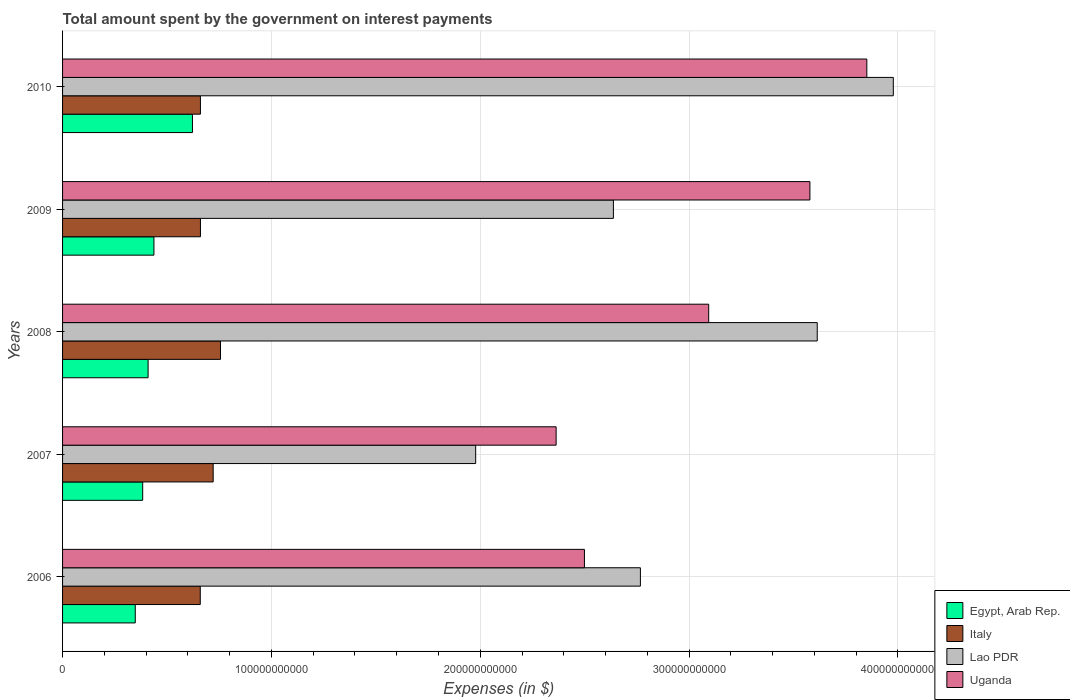How many different coloured bars are there?
Your answer should be compact. 4. How many groups of bars are there?
Make the answer very short. 5. Are the number of bars per tick equal to the number of legend labels?
Offer a terse response. Yes. How many bars are there on the 1st tick from the top?
Keep it short and to the point. 4. What is the label of the 4th group of bars from the top?
Your answer should be very brief. 2007. In how many cases, is the number of bars for a given year not equal to the number of legend labels?
Offer a terse response. 0. What is the amount spent on interest payments by the government in Egypt, Arab Rep. in 2006?
Provide a short and direct response. 3.48e+1. Across all years, what is the maximum amount spent on interest payments by the government in Egypt, Arab Rep.?
Your response must be concise. 6.22e+1. Across all years, what is the minimum amount spent on interest payments by the government in Uganda?
Your answer should be very brief. 2.36e+11. In which year was the amount spent on interest payments by the government in Uganda maximum?
Ensure brevity in your answer.  2010. In which year was the amount spent on interest payments by the government in Lao PDR minimum?
Your answer should be very brief. 2007. What is the total amount spent on interest payments by the government in Uganda in the graph?
Ensure brevity in your answer.  1.54e+12. What is the difference between the amount spent on interest payments by the government in Uganda in 2007 and that in 2008?
Make the answer very short. -7.31e+1. What is the difference between the amount spent on interest payments by the government in Uganda in 2009 and the amount spent on interest payments by the government in Italy in 2007?
Offer a terse response. 2.86e+11. What is the average amount spent on interest payments by the government in Uganda per year?
Make the answer very short. 3.08e+11. In the year 2008, what is the difference between the amount spent on interest payments by the government in Egypt, Arab Rep. and amount spent on interest payments by the government in Italy?
Keep it short and to the point. -3.47e+1. What is the ratio of the amount spent on interest payments by the government in Egypt, Arab Rep. in 2006 to that in 2007?
Make the answer very short. 0.91. Is the amount spent on interest payments by the government in Uganda in 2008 less than that in 2009?
Provide a short and direct response. Yes. What is the difference between the highest and the second highest amount spent on interest payments by the government in Italy?
Provide a short and direct response. 3.50e+09. What is the difference between the highest and the lowest amount spent on interest payments by the government in Egypt, Arab Rep.?
Your answer should be compact. 2.74e+1. What does the 3rd bar from the bottom in 2006 represents?
Make the answer very short. Lao PDR. Are all the bars in the graph horizontal?
Keep it short and to the point. Yes. What is the difference between two consecutive major ticks on the X-axis?
Provide a short and direct response. 1.00e+11. Are the values on the major ticks of X-axis written in scientific E-notation?
Offer a terse response. No. Does the graph contain any zero values?
Give a very brief answer. No. Does the graph contain grids?
Make the answer very short. Yes. Where does the legend appear in the graph?
Keep it short and to the point. Bottom right. How are the legend labels stacked?
Offer a terse response. Vertical. What is the title of the graph?
Your answer should be very brief. Total amount spent by the government on interest payments. What is the label or title of the X-axis?
Offer a very short reply. Expenses (in $). What is the Expenses (in $) of Egypt, Arab Rep. in 2006?
Make the answer very short. 3.48e+1. What is the Expenses (in $) in Italy in 2006?
Your answer should be compact. 6.59e+1. What is the Expenses (in $) of Lao PDR in 2006?
Provide a succinct answer. 2.77e+11. What is the Expenses (in $) in Uganda in 2006?
Make the answer very short. 2.50e+11. What is the Expenses (in $) of Egypt, Arab Rep. in 2007?
Ensure brevity in your answer.  3.84e+1. What is the Expenses (in $) in Italy in 2007?
Your answer should be compact. 7.21e+1. What is the Expenses (in $) of Lao PDR in 2007?
Make the answer very short. 1.98e+11. What is the Expenses (in $) in Uganda in 2007?
Keep it short and to the point. 2.36e+11. What is the Expenses (in $) of Egypt, Arab Rep. in 2008?
Your response must be concise. 4.10e+1. What is the Expenses (in $) of Italy in 2008?
Your answer should be very brief. 7.56e+1. What is the Expenses (in $) of Lao PDR in 2008?
Make the answer very short. 3.61e+11. What is the Expenses (in $) in Uganda in 2008?
Make the answer very short. 3.09e+11. What is the Expenses (in $) of Egypt, Arab Rep. in 2009?
Keep it short and to the point. 4.38e+1. What is the Expenses (in $) in Italy in 2009?
Make the answer very short. 6.60e+1. What is the Expenses (in $) in Lao PDR in 2009?
Your answer should be very brief. 2.64e+11. What is the Expenses (in $) in Uganda in 2009?
Your answer should be compact. 3.58e+11. What is the Expenses (in $) in Egypt, Arab Rep. in 2010?
Give a very brief answer. 6.22e+1. What is the Expenses (in $) of Italy in 2010?
Provide a short and direct response. 6.60e+1. What is the Expenses (in $) of Lao PDR in 2010?
Provide a short and direct response. 3.98e+11. What is the Expenses (in $) in Uganda in 2010?
Ensure brevity in your answer.  3.85e+11. Across all years, what is the maximum Expenses (in $) of Egypt, Arab Rep.?
Offer a very short reply. 6.22e+1. Across all years, what is the maximum Expenses (in $) of Italy?
Keep it short and to the point. 7.56e+1. Across all years, what is the maximum Expenses (in $) of Lao PDR?
Offer a terse response. 3.98e+11. Across all years, what is the maximum Expenses (in $) of Uganda?
Your answer should be compact. 3.85e+11. Across all years, what is the minimum Expenses (in $) in Egypt, Arab Rep.?
Keep it short and to the point. 3.48e+1. Across all years, what is the minimum Expenses (in $) of Italy?
Your response must be concise. 6.59e+1. Across all years, what is the minimum Expenses (in $) of Lao PDR?
Ensure brevity in your answer.  1.98e+11. Across all years, what is the minimum Expenses (in $) in Uganda?
Offer a terse response. 2.36e+11. What is the total Expenses (in $) in Egypt, Arab Rep. in the graph?
Provide a succinct answer. 2.20e+11. What is the total Expenses (in $) in Italy in the graph?
Offer a very short reply. 3.46e+11. What is the total Expenses (in $) in Lao PDR in the graph?
Ensure brevity in your answer.  1.50e+12. What is the total Expenses (in $) in Uganda in the graph?
Your answer should be compact. 1.54e+12. What is the difference between the Expenses (in $) in Egypt, Arab Rep. in 2006 and that in 2007?
Offer a terse response. -3.56e+09. What is the difference between the Expenses (in $) in Italy in 2006 and that in 2007?
Your answer should be compact. -6.18e+09. What is the difference between the Expenses (in $) in Lao PDR in 2006 and that in 2007?
Your response must be concise. 7.89e+1. What is the difference between the Expenses (in $) in Uganda in 2006 and that in 2007?
Ensure brevity in your answer.  1.36e+1. What is the difference between the Expenses (in $) in Egypt, Arab Rep. in 2006 and that in 2008?
Provide a succinct answer. -6.14e+09. What is the difference between the Expenses (in $) of Italy in 2006 and that in 2008?
Provide a succinct answer. -9.68e+09. What is the difference between the Expenses (in $) in Lao PDR in 2006 and that in 2008?
Offer a terse response. -8.47e+1. What is the difference between the Expenses (in $) in Uganda in 2006 and that in 2008?
Make the answer very short. -5.95e+1. What is the difference between the Expenses (in $) in Egypt, Arab Rep. in 2006 and that in 2009?
Provide a short and direct response. -8.94e+09. What is the difference between the Expenses (in $) of Italy in 2006 and that in 2009?
Provide a short and direct response. -8.80e+07. What is the difference between the Expenses (in $) in Lao PDR in 2006 and that in 2009?
Provide a succinct answer. 1.29e+1. What is the difference between the Expenses (in $) in Uganda in 2006 and that in 2009?
Offer a terse response. -1.08e+11. What is the difference between the Expenses (in $) in Egypt, Arab Rep. in 2006 and that in 2010?
Your answer should be compact. -2.74e+1. What is the difference between the Expenses (in $) of Italy in 2006 and that in 2010?
Provide a short and direct response. -7.20e+07. What is the difference between the Expenses (in $) of Lao PDR in 2006 and that in 2010?
Make the answer very short. -1.21e+11. What is the difference between the Expenses (in $) in Uganda in 2006 and that in 2010?
Offer a very short reply. -1.35e+11. What is the difference between the Expenses (in $) in Egypt, Arab Rep. in 2007 and that in 2008?
Offer a very short reply. -2.59e+09. What is the difference between the Expenses (in $) in Italy in 2007 and that in 2008?
Offer a terse response. -3.50e+09. What is the difference between the Expenses (in $) in Lao PDR in 2007 and that in 2008?
Make the answer very short. -1.64e+11. What is the difference between the Expenses (in $) of Uganda in 2007 and that in 2008?
Give a very brief answer. -7.31e+1. What is the difference between the Expenses (in $) in Egypt, Arab Rep. in 2007 and that in 2009?
Give a very brief answer. -5.39e+09. What is the difference between the Expenses (in $) of Italy in 2007 and that in 2009?
Your answer should be very brief. 6.09e+09. What is the difference between the Expenses (in $) in Lao PDR in 2007 and that in 2009?
Ensure brevity in your answer.  -6.60e+1. What is the difference between the Expenses (in $) of Uganda in 2007 and that in 2009?
Your answer should be compact. -1.22e+11. What is the difference between the Expenses (in $) of Egypt, Arab Rep. in 2007 and that in 2010?
Provide a succinct answer. -2.38e+1. What is the difference between the Expenses (in $) in Italy in 2007 and that in 2010?
Provide a succinct answer. 6.11e+09. What is the difference between the Expenses (in $) of Lao PDR in 2007 and that in 2010?
Keep it short and to the point. -2.00e+11. What is the difference between the Expenses (in $) in Uganda in 2007 and that in 2010?
Keep it short and to the point. -1.49e+11. What is the difference between the Expenses (in $) in Egypt, Arab Rep. in 2008 and that in 2009?
Offer a terse response. -2.80e+09. What is the difference between the Expenses (in $) in Italy in 2008 and that in 2009?
Provide a succinct answer. 9.59e+09. What is the difference between the Expenses (in $) in Lao PDR in 2008 and that in 2009?
Offer a terse response. 9.76e+1. What is the difference between the Expenses (in $) in Uganda in 2008 and that in 2009?
Your response must be concise. -4.85e+1. What is the difference between the Expenses (in $) in Egypt, Arab Rep. in 2008 and that in 2010?
Your response must be concise. -2.12e+1. What is the difference between the Expenses (in $) in Italy in 2008 and that in 2010?
Keep it short and to the point. 9.61e+09. What is the difference between the Expenses (in $) of Lao PDR in 2008 and that in 2010?
Your response must be concise. -3.64e+1. What is the difference between the Expenses (in $) in Uganda in 2008 and that in 2010?
Ensure brevity in your answer.  -7.57e+1. What is the difference between the Expenses (in $) in Egypt, Arab Rep. in 2009 and that in 2010?
Ensure brevity in your answer.  -1.84e+1. What is the difference between the Expenses (in $) in Italy in 2009 and that in 2010?
Make the answer very short. 1.60e+07. What is the difference between the Expenses (in $) of Lao PDR in 2009 and that in 2010?
Offer a terse response. -1.34e+11. What is the difference between the Expenses (in $) in Uganda in 2009 and that in 2010?
Make the answer very short. -2.73e+1. What is the difference between the Expenses (in $) of Egypt, Arab Rep. in 2006 and the Expenses (in $) of Italy in 2007?
Ensure brevity in your answer.  -3.73e+1. What is the difference between the Expenses (in $) of Egypt, Arab Rep. in 2006 and the Expenses (in $) of Lao PDR in 2007?
Your answer should be very brief. -1.63e+11. What is the difference between the Expenses (in $) of Egypt, Arab Rep. in 2006 and the Expenses (in $) of Uganda in 2007?
Provide a succinct answer. -2.02e+11. What is the difference between the Expenses (in $) of Italy in 2006 and the Expenses (in $) of Lao PDR in 2007?
Make the answer very short. -1.32e+11. What is the difference between the Expenses (in $) in Italy in 2006 and the Expenses (in $) in Uganda in 2007?
Keep it short and to the point. -1.70e+11. What is the difference between the Expenses (in $) in Lao PDR in 2006 and the Expenses (in $) in Uganda in 2007?
Offer a very short reply. 4.04e+1. What is the difference between the Expenses (in $) in Egypt, Arab Rep. in 2006 and the Expenses (in $) in Italy in 2008?
Your response must be concise. -4.08e+1. What is the difference between the Expenses (in $) of Egypt, Arab Rep. in 2006 and the Expenses (in $) of Lao PDR in 2008?
Keep it short and to the point. -3.27e+11. What is the difference between the Expenses (in $) of Egypt, Arab Rep. in 2006 and the Expenses (in $) of Uganda in 2008?
Provide a short and direct response. -2.75e+11. What is the difference between the Expenses (in $) in Italy in 2006 and the Expenses (in $) in Lao PDR in 2008?
Ensure brevity in your answer.  -2.95e+11. What is the difference between the Expenses (in $) of Italy in 2006 and the Expenses (in $) of Uganda in 2008?
Offer a very short reply. -2.43e+11. What is the difference between the Expenses (in $) of Lao PDR in 2006 and the Expenses (in $) of Uganda in 2008?
Your response must be concise. -3.27e+1. What is the difference between the Expenses (in $) of Egypt, Arab Rep. in 2006 and the Expenses (in $) of Italy in 2009?
Your answer should be compact. -3.12e+1. What is the difference between the Expenses (in $) of Egypt, Arab Rep. in 2006 and the Expenses (in $) of Lao PDR in 2009?
Ensure brevity in your answer.  -2.29e+11. What is the difference between the Expenses (in $) in Egypt, Arab Rep. in 2006 and the Expenses (in $) in Uganda in 2009?
Make the answer very short. -3.23e+11. What is the difference between the Expenses (in $) in Italy in 2006 and the Expenses (in $) in Lao PDR in 2009?
Make the answer very short. -1.98e+11. What is the difference between the Expenses (in $) of Italy in 2006 and the Expenses (in $) of Uganda in 2009?
Provide a succinct answer. -2.92e+11. What is the difference between the Expenses (in $) of Lao PDR in 2006 and the Expenses (in $) of Uganda in 2009?
Give a very brief answer. -8.12e+1. What is the difference between the Expenses (in $) in Egypt, Arab Rep. in 2006 and the Expenses (in $) in Italy in 2010?
Give a very brief answer. -3.12e+1. What is the difference between the Expenses (in $) in Egypt, Arab Rep. in 2006 and the Expenses (in $) in Lao PDR in 2010?
Keep it short and to the point. -3.63e+11. What is the difference between the Expenses (in $) in Egypt, Arab Rep. in 2006 and the Expenses (in $) in Uganda in 2010?
Provide a short and direct response. -3.50e+11. What is the difference between the Expenses (in $) of Italy in 2006 and the Expenses (in $) of Lao PDR in 2010?
Make the answer very short. -3.32e+11. What is the difference between the Expenses (in $) in Italy in 2006 and the Expenses (in $) in Uganda in 2010?
Make the answer very short. -3.19e+11. What is the difference between the Expenses (in $) of Lao PDR in 2006 and the Expenses (in $) of Uganda in 2010?
Give a very brief answer. -1.08e+11. What is the difference between the Expenses (in $) of Egypt, Arab Rep. in 2007 and the Expenses (in $) of Italy in 2008?
Ensure brevity in your answer.  -3.73e+1. What is the difference between the Expenses (in $) in Egypt, Arab Rep. in 2007 and the Expenses (in $) in Lao PDR in 2008?
Give a very brief answer. -3.23e+11. What is the difference between the Expenses (in $) in Egypt, Arab Rep. in 2007 and the Expenses (in $) in Uganda in 2008?
Your answer should be very brief. -2.71e+11. What is the difference between the Expenses (in $) of Italy in 2007 and the Expenses (in $) of Lao PDR in 2008?
Provide a short and direct response. -2.89e+11. What is the difference between the Expenses (in $) in Italy in 2007 and the Expenses (in $) in Uganda in 2008?
Provide a succinct answer. -2.37e+11. What is the difference between the Expenses (in $) of Lao PDR in 2007 and the Expenses (in $) of Uganda in 2008?
Keep it short and to the point. -1.12e+11. What is the difference between the Expenses (in $) of Egypt, Arab Rep. in 2007 and the Expenses (in $) of Italy in 2009?
Your answer should be very brief. -2.77e+1. What is the difference between the Expenses (in $) of Egypt, Arab Rep. in 2007 and the Expenses (in $) of Lao PDR in 2009?
Your answer should be very brief. -2.25e+11. What is the difference between the Expenses (in $) of Egypt, Arab Rep. in 2007 and the Expenses (in $) of Uganda in 2009?
Ensure brevity in your answer.  -3.20e+11. What is the difference between the Expenses (in $) in Italy in 2007 and the Expenses (in $) in Lao PDR in 2009?
Ensure brevity in your answer.  -1.92e+11. What is the difference between the Expenses (in $) in Italy in 2007 and the Expenses (in $) in Uganda in 2009?
Provide a succinct answer. -2.86e+11. What is the difference between the Expenses (in $) of Lao PDR in 2007 and the Expenses (in $) of Uganda in 2009?
Provide a succinct answer. -1.60e+11. What is the difference between the Expenses (in $) in Egypt, Arab Rep. in 2007 and the Expenses (in $) in Italy in 2010?
Ensure brevity in your answer.  -2.76e+1. What is the difference between the Expenses (in $) in Egypt, Arab Rep. in 2007 and the Expenses (in $) in Lao PDR in 2010?
Provide a short and direct response. -3.59e+11. What is the difference between the Expenses (in $) in Egypt, Arab Rep. in 2007 and the Expenses (in $) in Uganda in 2010?
Provide a short and direct response. -3.47e+11. What is the difference between the Expenses (in $) of Italy in 2007 and the Expenses (in $) of Lao PDR in 2010?
Offer a terse response. -3.26e+11. What is the difference between the Expenses (in $) of Italy in 2007 and the Expenses (in $) of Uganda in 2010?
Provide a short and direct response. -3.13e+11. What is the difference between the Expenses (in $) in Lao PDR in 2007 and the Expenses (in $) in Uganda in 2010?
Your answer should be compact. -1.87e+11. What is the difference between the Expenses (in $) in Egypt, Arab Rep. in 2008 and the Expenses (in $) in Italy in 2009?
Provide a succinct answer. -2.51e+1. What is the difference between the Expenses (in $) of Egypt, Arab Rep. in 2008 and the Expenses (in $) of Lao PDR in 2009?
Offer a very short reply. -2.23e+11. What is the difference between the Expenses (in $) of Egypt, Arab Rep. in 2008 and the Expenses (in $) of Uganda in 2009?
Offer a very short reply. -3.17e+11. What is the difference between the Expenses (in $) in Italy in 2008 and the Expenses (in $) in Lao PDR in 2009?
Provide a short and direct response. -1.88e+11. What is the difference between the Expenses (in $) of Italy in 2008 and the Expenses (in $) of Uganda in 2009?
Keep it short and to the point. -2.82e+11. What is the difference between the Expenses (in $) in Lao PDR in 2008 and the Expenses (in $) in Uganda in 2009?
Offer a terse response. 3.51e+09. What is the difference between the Expenses (in $) in Egypt, Arab Rep. in 2008 and the Expenses (in $) in Italy in 2010?
Make the answer very short. -2.51e+1. What is the difference between the Expenses (in $) of Egypt, Arab Rep. in 2008 and the Expenses (in $) of Lao PDR in 2010?
Your response must be concise. -3.57e+11. What is the difference between the Expenses (in $) of Egypt, Arab Rep. in 2008 and the Expenses (in $) of Uganda in 2010?
Give a very brief answer. -3.44e+11. What is the difference between the Expenses (in $) of Italy in 2008 and the Expenses (in $) of Lao PDR in 2010?
Offer a very short reply. -3.22e+11. What is the difference between the Expenses (in $) of Italy in 2008 and the Expenses (in $) of Uganda in 2010?
Your answer should be very brief. -3.10e+11. What is the difference between the Expenses (in $) in Lao PDR in 2008 and the Expenses (in $) in Uganda in 2010?
Your answer should be compact. -2.37e+1. What is the difference between the Expenses (in $) of Egypt, Arab Rep. in 2009 and the Expenses (in $) of Italy in 2010?
Make the answer very short. -2.23e+1. What is the difference between the Expenses (in $) in Egypt, Arab Rep. in 2009 and the Expenses (in $) in Lao PDR in 2010?
Offer a terse response. -3.54e+11. What is the difference between the Expenses (in $) in Egypt, Arab Rep. in 2009 and the Expenses (in $) in Uganda in 2010?
Offer a very short reply. -3.41e+11. What is the difference between the Expenses (in $) in Italy in 2009 and the Expenses (in $) in Lao PDR in 2010?
Provide a short and direct response. -3.32e+11. What is the difference between the Expenses (in $) in Italy in 2009 and the Expenses (in $) in Uganda in 2010?
Ensure brevity in your answer.  -3.19e+11. What is the difference between the Expenses (in $) of Lao PDR in 2009 and the Expenses (in $) of Uganda in 2010?
Your answer should be very brief. -1.21e+11. What is the average Expenses (in $) in Egypt, Arab Rep. per year?
Provide a short and direct response. 4.40e+1. What is the average Expenses (in $) of Italy per year?
Your response must be concise. 6.91e+1. What is the average Expenses (in $) of Lao PDR per year?
Offer a terse response. 2.99e+11. What is the average Expenses (in $) in Uganda per year?
Provide a succinct answer. 3.08e+11. In the year 2006, what is the difference between the Expenses (in $) in Egypt, Arab Rep. and Expenses (in $) in Italy?
Make the answer very short. -3.11e+1. In the year 2006, what is the difference between the Expenses (in $) in Egypt, Arab Rep. and Expenses (in $) in Lao PDR?
Make the answer very short. -2.42e+11. In the year 2006, what is the difference between the Expenses (in $) of Egypt, Arab Rep. and Expenses (in $) of Uganda?
Offer a terse response. -2.15e+11. In the year 2006, what is the difference between the Expenses (in $) of Italy and Expenses (in $) of Lao PDR?
Provide a short and direct response. -2.11e+11. In the year 2006, what is the difference between the Expenses (in $) in Italy and Expenses (in $) in Uganda?
Give a very brief answer. -1.84e+11. In the year 2006, what is the difference between the Expenses (in $) in Lao PDR and Expenses (in $) in Uganda?
Provide a succinct answer. 2.68e+1. In the year 2007, what is the difference between the Expenses (in $) in Egypt, Arab Rep. and Expenses (in $) in Italy?
Provide a short and direct response. -3.38e+1. In the year 2007, what is the difference between the Expenses (in $) in Egypt, Arab Rep. and Expenses (in $) in Lao PDR?
Keep it short and to the point. -1.59e+11. In the year 2007, what is the difference between the Expenses (in $) of Egypt, Arab Rep. and Expenses (in $) of Uganda?
Offer a very short reply. -1.98e+11. In the year 2007, what is the difference between the Expenses (in $) of Italy and Expenses (in $) of Lao PDR?
Your answer should be very brief. -1.26e+11. In the year 2007, what is the difference between the Expenses (in $) in Italy and Expenses (in $) in Uganda?
Make the answer very short. -1.64e+11. In the year 2007, what is the difference between the Expenses (in $) in Lao PDR and Expenses (in $) in Uganda?
Your answer should be compact. -3.85e+1. In the year 2008, what is the difference between the Expenses (in $) of Egypt, Arab Rep. and Expenses (in $) of Italy?
Give a very brief answer. -3.47e+1. In the year 2008, what is the difference between the Expenses (in $) of Egypt, Arab Rep. and Expenses (in $) of Lao PDR?
Offer a terse response. -3.20e+11. In the year 2008, what is the difference between the Expenses (in $) in Egypt, Arab Rep. and Expenses (in $) in Uganda?
Offer a very short reply. -2.68e+11. In the year 2008, what is the difference between the Expenses (in $) in Italy and Expenses (in $) in Lao PDR?
Provide a succinct answer. -2.86e+11. In the year 2008, what is the difference between the Expenses (in $) in Italy and Expenses (in $) in Uganda?
Ensure brevity in your answer.  -2.34e+11. In the year 2008, what is the difference between the Expenses (in $) in Lao PDR and Expenses (in $) in Uganda?
Make the answer very short. 5.20e+1. In the year 2009, what is the difference between the Expenses (in $) of Egypt, Arab Rep. and Expenses (in $) of Italy?
Offer a very short reply. -2.23e+1. In the year 2009, what is the difference between the Expenses (in $) in Egypt, Arab Rep. and Expenses (in $) in Lao PDR?
Give a very brief answer. -2.20e+11. In the year 2009, what is the difference between the Expenses (in $) in Egypt, Arab Rep. and Expenses (in $) in Uganda?
Offer a terse response. -3.14e+11. In the year 2009, what is the difference between the Expenses (in $) of Italy and Expenses (in $) of Lao PDR?
Give a very brief answer. -1.98e+11. In the year 2009, what is the difference between the Expenses (in $) in Italy and Expenses (in $) in Uganda?
Give a very brief answer. -2.92e+11. In the year 2009, what is the difference between the Expenses (in $) in Lao PDR and Expenses (in $) in Uganda?
Your response must be concise. -9.41e+1. In the year 2010, what is the difference between the Expenses (in $) of Egypt, Arab Rep. and Expenses (in $) of Italy?
Give a very brief answer. -3.82e+09. In the year 2010, what is the difference between the Expenses (in $) in Egypt, Arab Rep. and Expenses (in $) in Lao PDR?
Your answer should be very brief. -3.36e+11. In the year 2010, what is the difference between the Expenses (in $) in Egypt, Arab Rep. and Expenses (in $) in Uganda?
Provide a succinct answer. -3.23e+11. In the year 2010, what is the difference between the Expenses (in $) of Italy and Expenses (in $) of Lao PDR?
Your answer should be compact. -3.32e+11. In the year 2010, what is the difference between the Expenses (in $) in Italy and Expenses (in $) in Uganda?
Give a very brief answer. -3.19e+11. In the year 2010, what is the difference between the Expenses (in $) in Lao PDR and Expenses (in $) in Uganda?
Your answer should be compact. 1.27e+1. What is the ratio of the Expenses (in $) of Egypt, Arab Rep. in 2006 to that in 2007?
Keep it short and to the point. 0.91. What is the ratio of the Expenses (in $) of Italy in 2006 to that in 2007?
Provide a succinct answer. 0.91. What is the ratio of the Expenses (in $) in Lao PDR in 2006 to that in 2007?
Your answer should be compact. 1.4. What is the ratio of the Expenses (in $) in Uganda in 2006 to that in 2007?
Ensure brevity in your answer.  1.06. What is the ratio of the Expenses (in $) of Italy in 2006 to that in 2008?
Provide a succinct answer. 0.87. What is the ratio of the Expenses (in $) of Lao PDR in 2006 to that in 2008?
Offer a terse response. 0.77. What is the ratio of the Expenses (in $) of Uganda in 2006 to that in 2008?
Provide a succinct answer. 0.81. What is the ratio of the Expenses (in $) in Egypt, Arab Rep. in 2006 to that in 2009?
Keep it short and to the point. 0.8. What is the ratio of the Expenses (in $) of Italy in 2006 to that in 2009?
Offer a very short reply. 1. What is the ratio of the Expenses (in $) of Lao PDR in 2006 to that in 2009?
Offer a very short reply. 1.05. What is the ratio of the Expenses (in $) of Uganda in 2006 to that in 2009?
Your answer should be compact. 0.7. What is the ratio of the Expenses (in $) of Egypt, Arab Rep. in 2006 to that in 2010?
Provide a succinct answer. 0.56. What is the ratio of the Expenses (in $) of Italy in 2006 to that in 2010?
Make the answer very short. 1. What is the ratio of the Expenses (in $) of Lao PDR in 2006 to that in 2010?
Make the answer very short. 0.7. What is the ratio of the Expenses (in $) in Uganda in 2006 to that in 2010?
Offer a very short reply. 0.65. What is the ratio of the Expenses (in $) of Egypt, Arab Rep. in 2007 to that in 2008?
Your response must be concise. 0.94. What is the ratio of the Expenses (in $) in Italy in 2007 to that in 2008?
Your answer should be very brief. 0.95. What is the ratio of the Expenses (in $) of Lao PDR in 2007 to that in 2008?
Provide a succinct answer. 0.55. What is the ratio of the Expenses (in $) of Uganda in 2007 to that in 2008?
Your response must be concise. 0.76. What is the ratio of the Expenses (in $) in Egypt, Arab Rep. in 2007 to that in 2009?
Ensure brevity in your answer.  0.88. What is the ratio of the Expenses (in $) in Italy in 2007 to that in 2009?
Provide a short and direct response. 1.09. What is the ratio of the Expenses (in $) of Lao PDR in 2007 to that in 2009?
Ensure brevity in your answer.  0.75. What is the ratio of the Expenses (in $) in Uganda in 2007 to that in 2009?
Provide a short and direct response. 0.66. What is the ratio of the Expenses (in $) in Egypt, Arab Rep. in 2007 to that in 2010?
Offer a very short reply. 0.62. What is the ratio of the Expenses (in $) in Italy in 2007 to that in 2010?
Offer a very short reply. 1.09. What is the ratio of the Expenses (in $) in Lao PDR in 2007 to that in 2010?
Give a very brief answer. 0.5. What is the ratio of the Expenses (in $) of Uganda in 2007 to that in 2010?
Offer a very short reply. 0.61. What is the ratio of the Expenses (in $) in Egypt, Arab Rep. in 2008 to that in 2009?
Make the answer very short. 0.94. What is the ratio of the Expenses (in $) in Italy in 2008 to that in 2009?
Keep it short and to the point. 1.15. What is the ratio of the Expenses (in $) of Lao PDR in 2008 to that in 2009?
Keep it short and to the point. 1.37. What is the ratio of the Expenses (in $) in Uganda in 2008 to that in 2009?
Ensure brevity in your answer.  0.86. What is the ratio of the Expenses (in $) of Egypt, Arab Rep. in 2008 to that in 2010?
Keep it short and to the point. 0.66. What is the ratio of the Expenses (in $) in Italy in 2008 to that in 2010?
Your response must be concise. 1.15. What is the ratio of the Expenses (in $) of Lao PDR in 2008 to that in 2010?
Offer a terse response. 0.91. What is the ratio of the Expenses (in $) of Uganda in 2008 to that in 2010?
Give a very brief answer. 0.8. What is the ratio of the Expenses (in $) in Egypt, Arab Rep. in 2009 to that in 2010?
Provide a short and direct response. 0.7. What is the ratio of the Expenses (in $) of Italy in 2009 to that in 2010?
Your answer should be compact. 1. What is the ratio of the Expenses (in $) in Lao PDR in 2009 to that in 2010?
Your answer should be compact. 0.66. What is the ratio of the Expenses (in $) of Uganda in 2009 to that in 2010?
Keep it short and to the point. 0.93. What is the difference between the highest and the second highest Expenses (in $) in Egypt, Arab Rep.?
Your answer should be very brief. 1.84e+1. What is the difference between the highest and the second highest Expenses (in $) in Italy?
Ensure brevity in your answer.  3.50e+09. What is the difference between the highest and the second highest Expenses (in $) of Lao PDR?
Keep it short and to the point. 3.64e+1. What is the difference between the highest and the second highest Expenses (in $) of Uganda?
Provide a succinct answer. 2.73e+1. What is the difference between the highest and the lowest Expenses (in $) in Egypt, Arab Rep.?
Provide a succinct answer. 2.74e+1. What is the difference between the highest and the lowest Expenses (in $) in Italy?
Keep it short and to the point. 9.68e+09. What is the difference between the highest and the lowest Expenses (in $) in Lao PDR?
Your answer should be compact. 2.00e+11. What is the difference between the highest and the lowest Expenses (in $) in Uganda?
Provide a succinct answer. 1.49e+11. 